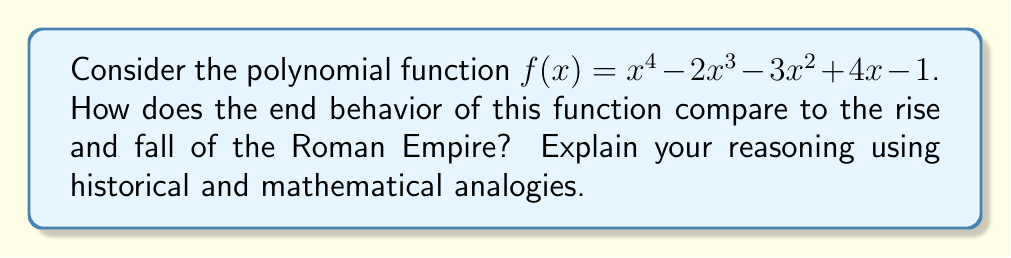Give your solution to this math problem. To analyze the end behavior of the polynomial function and compare it to the Roman Empire, let's follow these steps:

1. Determine the degree and leading coefficient:
   The polynomial $f(x) = x^4 - 2x^3 - 3x^2 + 4x - 1$ has a degree of 4, and the leading coefficient is 1 (positive).

2. End behavior of the polynomial:
   For a polynomial with even degree and positive leading coefficient, the end behavior is:
   As $x \to +\infty$, $f(x) \to +\infty$
   As $x \to -\infty$, $f(x) \to +\infty$

3. Visualize the general shape:
   The function will have a U-shaped graph that opens upward on both ends.

4. Historical analogy:
   The Roman Empire's history can be divided into three main periods:
   a) Rise (753 BC - 27 BC): Republic era
   b) Peak (27 BC - 180 AD): Early Empire (Pax Romana)
   c) Decline and Fall (180 AD - 476 AD): Late Empire

5. Comparison:
   - The left side of the polynomial graph (negative x-values) can represent the rise of the Roman Empire. As we move from left to right (forward in time), the function values increase, similar to the growing power and influence of Rome.
   - The bottom of the U-shape could represent the peak of the Roman Empire during the Pax Romana.
   - The right side of the polynomial graph (positive x-values) can represent the decline and fall of the Roman Empire. As we continue moving right, the function values increase again, which might seem contradictory to the empire's fall.

6. Interpretation:
   The key difference is that while the polynomial function rises indefinitely on both ends, the Roman Empire eventually fell. This highlights a limitation of the mathematical model in representing historical events. The polynomial can be seen as representing the lasting impact and legacy of the Roman Empire, which continues to influence modern civilization long after its political fall.
Answer: The polynomial's U-shape with upward-opening ends parallels Rome's rise and peak but diverges in representing its fall, illustrating both the similarities and limitations of mathematical models in historical analysis. 